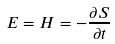<formula> <loc_0><loc_0><loc_500><loc_500>E = H = - \frac { \partial S } { \partial t }</formula> 